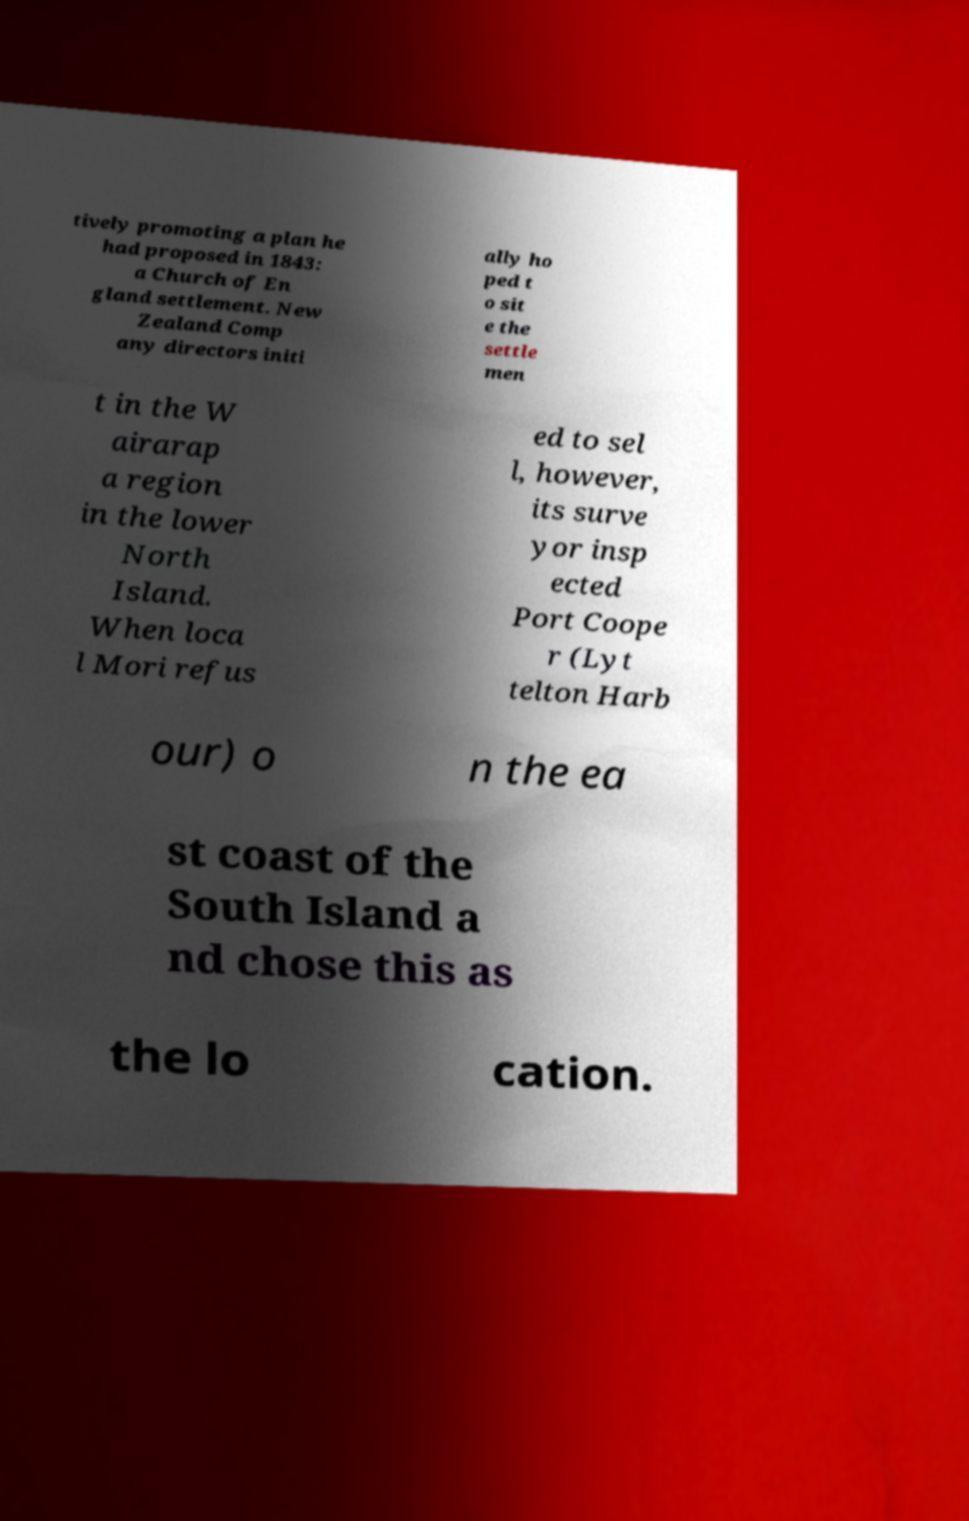There's text embedded in this image that I need extracted. Can you transcribe it verbatim? tively promoting a plan he had proposed in 1843: a Church of En gland settlement. New Zealand Comp any directors initi ally ho ped t o sit e the settle men t in the W airarap a region in the lower North Island. When loca l Mori refus ed to sel l, however, its surve yor insp ected Port Coope r (Lyt telton Harb our) o n the ea st coast of the South Island a nd chose this as the lo cation. 